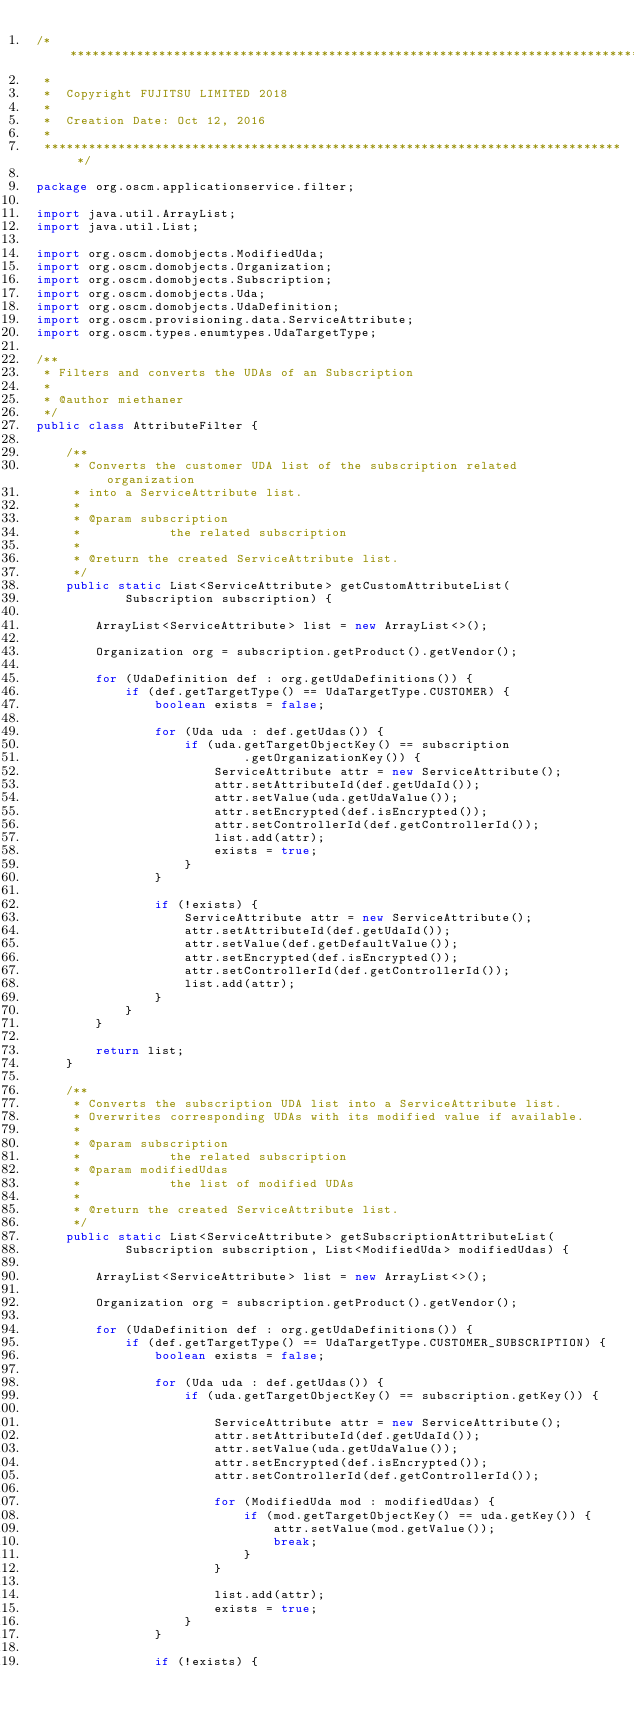Convert code to text. <code><loc_0><loc_0><loc_500><loc_500><_Java_>/*******************************************************************************
 *                                                                              
 *  Copyright FUJITSU LIMITED 2018
 *                                                                                                                                 
 *  Creation Date: Oct 12, 2016                                                      
 *                                                                              
 *******************************************************************************/

package org.oscm.applicationservice.filter;

import java.util.ArrayList;
import java.util.List;

import org.oscm.domobjects.ModifiedUda;
import org.oscm.domobjects.Organization;
import org.oscm.domobjects.Subscription;
import org.oscm.domobjects.Uda;
import org.oscm.domobjects.UdaDefinition;
import org.oscm.provisioning.data.ServiceAttribute;
import org.oscm.types.enumtypes.UdaTargetType;

/**
 * Filters and converts the UDAs of an Subscription
 * 
 * @author miethaner
 */
public class AttributeFilter {

    /**
     * Converts the customer UDA list of the subscription related organization
     * into a ServiceAttribute list.
     * 
     * @param subscription
     *            the related subscription
     * 
     * @return the created ServiceAttribute list.
     */
    public static List<ServiceAttribute> getCustomAttributeList(
            Subscription subscription) {

        ArrayList<ServiceAttribute> list = new ArrayList<>();

        Organization org = subscription.getProduct().getVendor();

        for (UdaDefinition def : org.getUdaDefinitions()) {
            if (def.getTargetType() == UdaTargetType.CUSTOMER) {
                boolean exists = false;

                for (Uda uda : def.getUdas()) {
                    if (uda.getTargetObjectKey() == subscription
                            .getOrganizationKey()) {
                        ServiceAttribute attr = new ServiceAttribute();
                        attr.setAttributeId(def.getUdaId());
                        attr.setValue(uda.getUdaValue());
                        attr.setEncrypted(def.isEncrypted());
                        attr.setControllerId(def.getControllerId());
                        list.add(attr);
                        exists = true;
                    }
                }

                if (!exists) {
                    ServiceAttribute attr = new ServiceAttribute();
                    attr.setAttributeId(def.getUdaId());
                    attr.setValue(def.getDefaultValue());
                    attr.setEncrypted(def.isEncrypted());
                    attr.setControllerId(def.getControllerId());
                    list.add(attr);
                }
            }
        }

        return list;
    }

    /**
     * Converts the subscription UDA list into a ServiceAttribute list.
     * Overwrites corresponding UDAs with its modified value if available.
     * 
     * @param subscription
     *            the related subscription
     * @param modifiedUdas
     *            the list of modified UDAs
     * 
     * @return the created ServiceAttribute list.
     */
    public static List<ServiceAttribute> getSubscriptionAttributeList(
            Subscription subscription, List<ModifiedUda> modifiedUdas) {

        ArrayList<ServiceAttribute> list = new ArrayList<>();

        Organization org = subscription.getProduct().getVendor();

        for (UdaDefinition def : org.getUdaDefinitions()) {
            if (def.getTargetType() == UdaTargetType.CUSTOMER_SUBSCRIPTION) {
                boolean exists = false;

                for (Uda uda : def.getUdas()) {
                    if (uda.getTargetObjectKey() == subscription.getKey()) {

                        ServiceAttribute attr = new ServiceAttribute();
                        attr.setAttributeId(def.getUdaId());
                        attr.setValue(uda.getUdaValue());
                        attr.setEncrypted(def.isEncrypted());
                        attr.setControllerId(def.getControllerId());

                        for (ModifiedUda mod : modifiedUdas) {
                            if (mod.getTargetObjectKey() == uda.getKey()) {
                                attr.setValue(mod.getValue());
                                break;
                            }
                        }

                        list.add(attr);
                        exists = true;
                    }
                }

                if (!exists) {</code> 